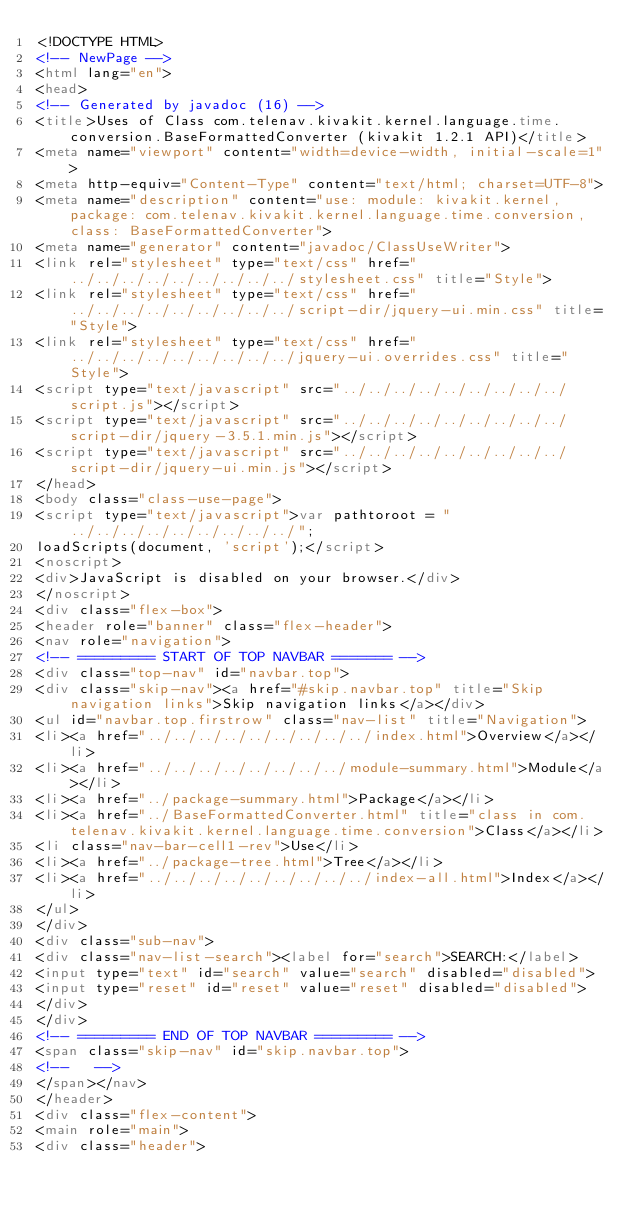Convert code to text. <code><loc_0><loc_0><loc_500><loc_500><_HTML_><!DOCTYPE HTML>
<!-- NewPage -->
<html lang="en">
<head>
<!-- Generated by javadoc (16) -->
<title>Uses of Class com.telenav.kivakit.kernel.language.time.conversion.BaseFormattedConverter (kivakit 1.2.1 API)</title>
<meta name="viewport" content="width=device-width, initial-scale=1">
<meta http-equiv="Content-Type" content="text/html; charset=UTF-8">
<meta name="description" content="use: module: kivakit.kernel, package: com.telenav.kivakit.kernel.language.time.conversion, class: BaseFormattedConverter">
<meta name="generator" content="javadoc/ClassUseWriter">
<link rel="stylesheet" type="text/css" href="../../../../../../../../../stylesheet.css" title="Style">
<link rel="stylesheet" type="text/css" href="../../../../../../../../../script-dir/jquery-ui.min.css" title="Style">
<link rel="stylesheet" type="text/css" href="../../../../../../../../../jquery-ui.overrides.css" title="Style">
<script type="text/javascript" src="../../../../../../../../../script.js"></script>
<script type="text/javascript" src="../../../../../../../../../script-dir/jquery-3.5.1.min.js"></script>
<script type="text/javascript" src="../../../../../../../../../script-dir/jquery-ui.min.js"></script>
</head>
<body class="class-use-page">
<script type="text/javascript">var pathtoroot = "../../../../../../../../../";
loadScripts(document, 'script');</script>
<noscript>
<div>JavaScript is disabled on your browser.</div>
</noscript>
<div class="flex-box">
<header role="banner" class="flex-header">
<nav role="navigation">
<!-- ========= START OF TOP NAVBAR ======= -->
<div class="top-nav" id="navbar.top">
<div class="skip-nav"><a href="#skip.navbar.top" title="Skip navigation links">Skip navigation links</a></div>
<ul id="navbar.top.firstrow" class="nav-list" title="Navigation">
<li><a href="../../../../../../../../../index.html">Overview</a></li>
<li><a href="../../../../../../../../module-summary.html">Module</a></li>
<li><a href="../package-summary.html">Package</a></li>
<li><a href="../BaseFormattedConverter.html" title="class in com.telenav.kivakit.kernel.language.time.conversion">Class</a></li>
<li class="nav-bar-cell1-rev">Use</li>
<li><a href="../package-tree.html">Tree</a></li>
<li><a href="../../../../../../../../../index-all.html">Index</a></li>
</ul>
</div>
<div class="sub-nav">
<div class="nav-list-search"><label for="search">SEARCH:</label>
<input type="text" id="search" value="search" disabled="disabled">
<input type="reset" id="reset" value="reset" disabled="disabled">
</div>
</div>
<!-- ========= END OF TOP NAVBAR ========= -->
<span class="skip-nav" id="skip.navbar.top">
<!--   -->
</span></nav>
</header>
<div class="flex-content">
<main role="main">
<div class="header"></code> 